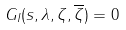Convert formula to latex. <formula><loc_0><loc_0><loc_500><loc_500>G _ { I } ( s , \lambda , \zeta , \overline { \zeta } ) = 0</formula> 